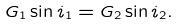Convert formula to latex. <formula><loc_0><loc_0><loc_500><loc_500>G _ { 1 } \sin i _ { 1 } = G _ { 2 } \sin i _ { 2 } .</formula> 